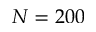<formula> <loc_0><loc_0><loc_500><loc_500>N = 2 0 0</formula> 